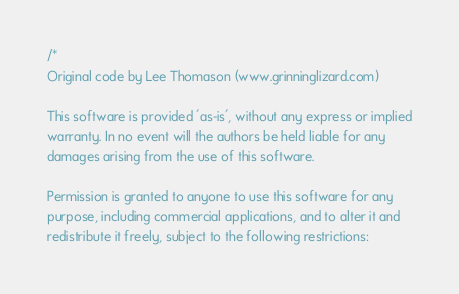Convert code to text. <code><loc_0><loc_0><loc_500><loc_500><_C++_>/*
Original code by Lee Thomason (www.grinninglizard.com)

This software is provided 'as-is', without any express or implied
warranty. In no event will the authors be held liable for any
damages arising from the use of this software.

Permission is granted to anyone to use this software for any
purpose, including commercial applications, and to alter it and
redistribute it freely, subject to the following restrictions:
</code> 